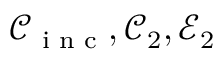<formula> <loc_0><loc_0><loc_500><loc_500>\mathcal { C } _ { i n c } , \mathcal { C } _ { 2 } , \mathcal { E } _ { 2 }</formula> 